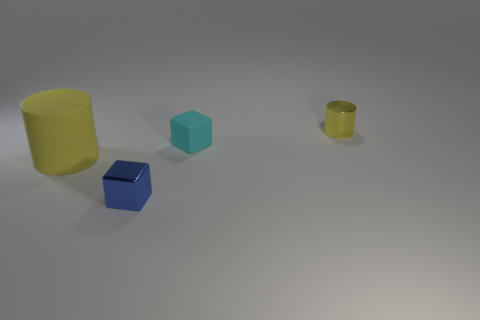The cyan matte block is what size?
Provide a succinct answer. Small. Is the big object made of the same material as the small cylinder?
Provide a short and direct response. No. How many rubber cylinders are to the left of the cube on the right side of the shiny object left of the yellow metallic cylinder?
Offer a very short reply. 1. The tiny shiny thing behind the large yellow thing has what shape?
Keep it short and to the point. Cylinder. How many other things are made of the same material as the large yellow object?
Provide a short and direct response. 1. Is the color of the big rubber cylinder the same as the tiny metallic cylinder?
Make the answer very short. Yes. Are there fewer cyan cubes that are in front of the cyan thing than small cyan cubes that are to the left of the metal cylinder?
Your answer should be compact. Yes. What is the color of the big thing that is the same shape as the small yellow shiny object?
Your response must be concise. Yellow. There is a yellow cylinder that is to the right of the cyan matte object; does it have the same size as the tiny cyan matte block?
Your response must be concise. Yes. Is the number of cyan matte cubes in front of the cyan block less than the number of small cyan rubber blocks?
Provide a short and direct response. Yes. 